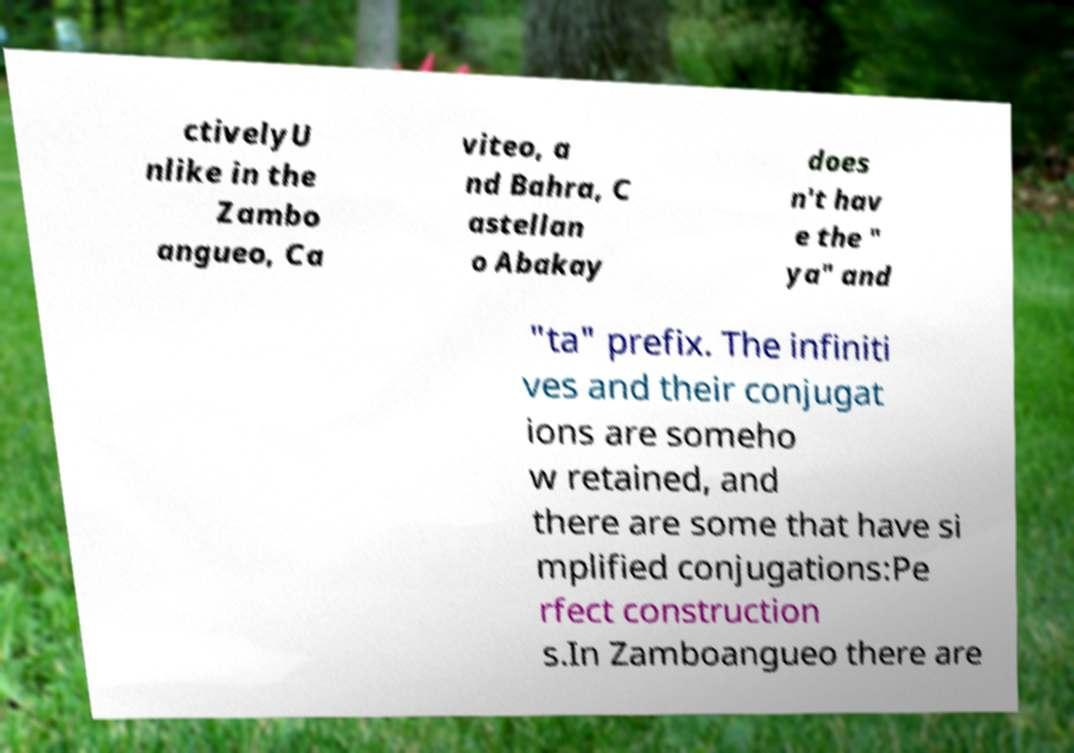Could you assist in decoding the text presented in this image and type it out clearly? ctivelyU nlike in the Zambo angueo, Ca viteo, a nd Bahra, C astellan o Abakay does n't hav e the " ya" and "ta" prefix. The infiniti ves and their conjugat ions are someho w retained, and there are some that have si mplified conjugations:Pe rfect construction s.In Zamboangueo there are 